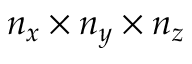<formula> <loc_0><loc_0><loc_500><loc_500>n _ { x } \times n _ { y } \times n _ { z }</formula> 